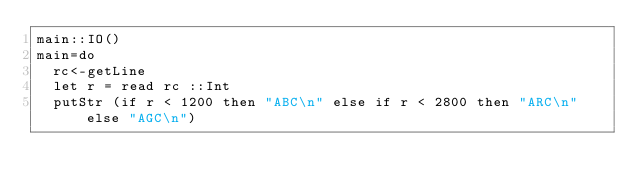<code> <loc_0><loc_0><loc_500><loc_500><_Haskell_>main::IO()
main=do
  rc<-getLine
  let r = read rc ::Int
  putStr (if r < 1200 then "ABC\n" else if r < 2800 then "ARC\n" else "AGC\n") </code> 